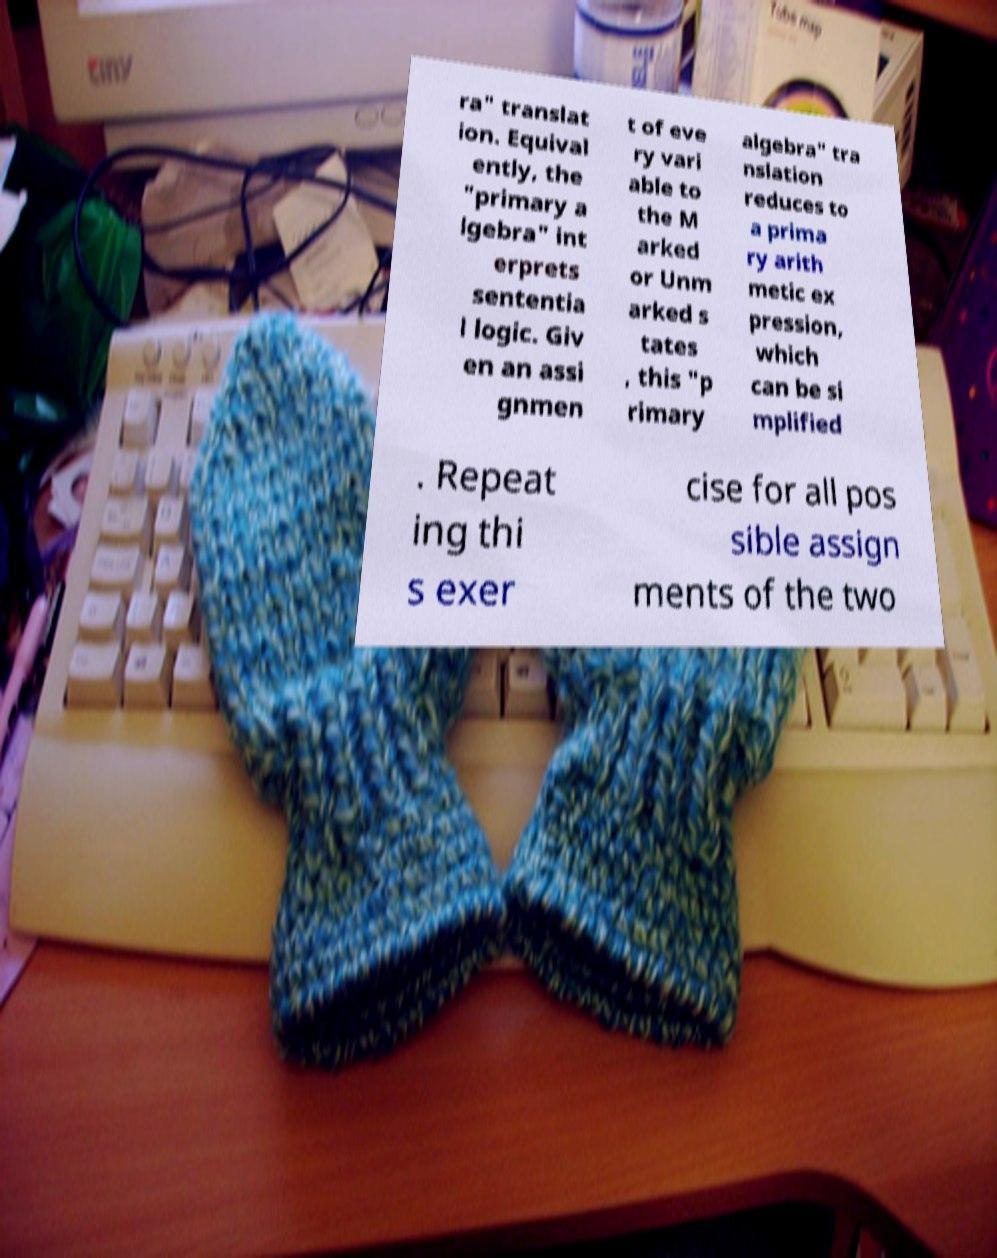For documentation purposes, I need the text within this image transcribed. Could you provide that? ra" translat ion. Equival ently, the "primary a lgebra" int erprets sententia l logic. Giv en an assi gnmen t of eve ry vari able to the M arked or Unm arked s tates , this "p rimary algebra" tra nslation reduces to a prima ry arith metic ex pression, which can be si mplified . Repeat ing thi s exer cise for all pos sible assign ments of the two 